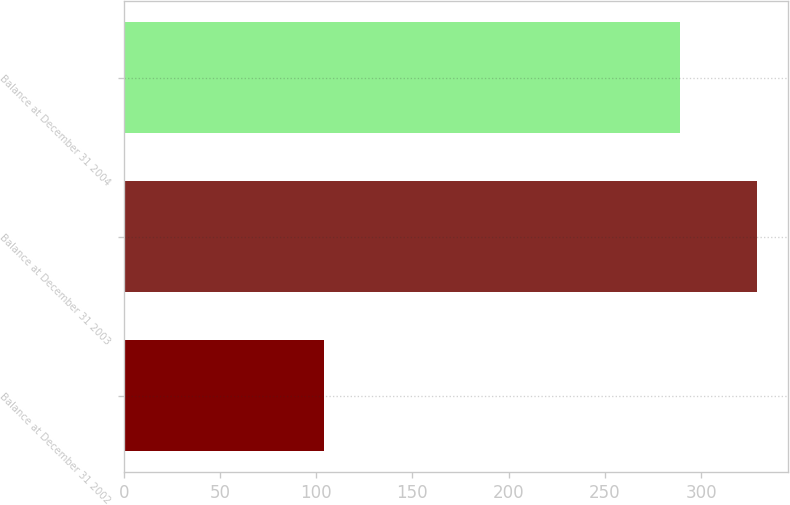Convert chart. <chart><loc_0><loc_0><loc_500><loc_500><bar_chart><fcel>Balance at December 31 2002<fcel>Balance at December 31 2003<fcel>Balance at December 31 2004<nl><fcel>104<fcel>329<fcel>289<nl></chart> 